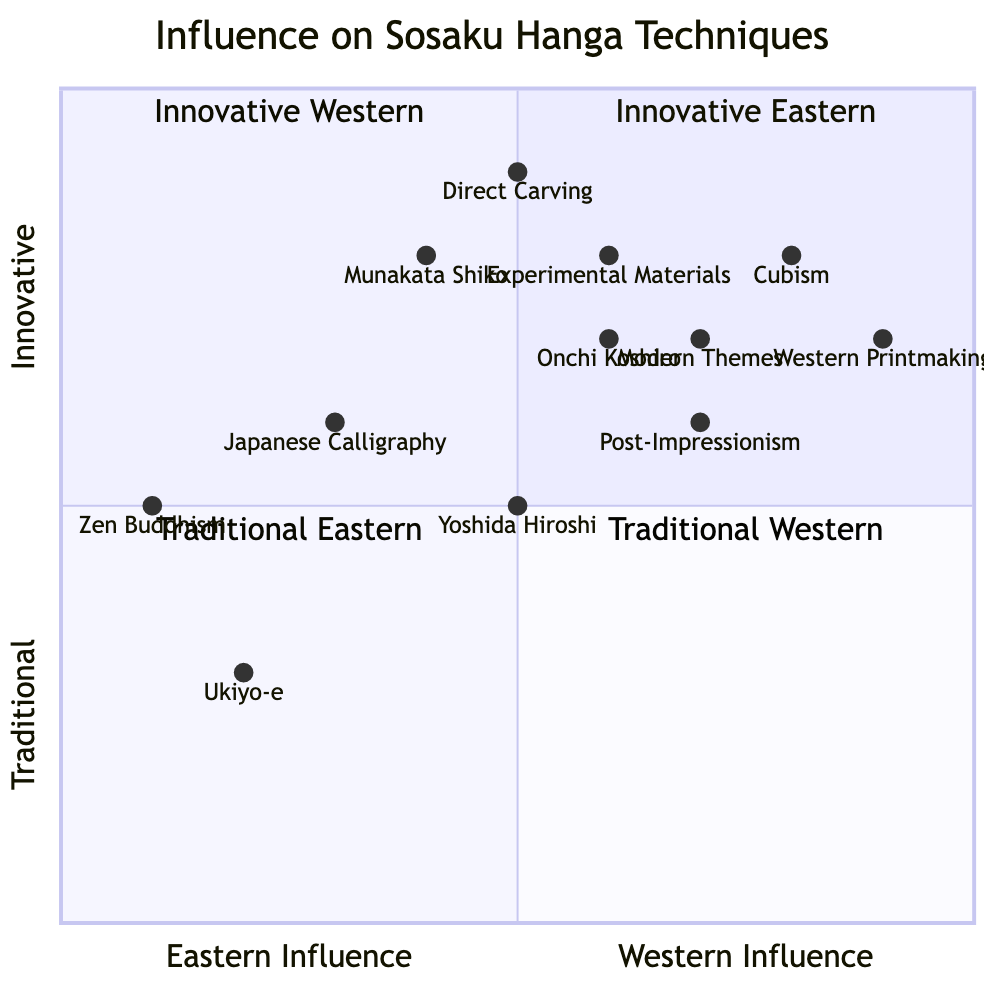What is the value of Zen Buddhism on the chart? The node representing Zen Buddhism is located at [0.1, 0.5]. The vertical coordinate, which indicates its innovative nature, is 0.5, reflecting that it is considered traditional from the perspective of innovative creativity.
Answer: [0.1, 0.5] Which technique has the highest innovative value? Looking at the y-axis values, the technique "Direct Carving" is at [0.5, 0.9], which is the highest on the chart. Therefore, this technique is identified as the most innovative.
Answer: Direct Carving How many influences are located in the Innovative Eastern quadrant? In the Innovative Eastern quadrant, there are three influences present: Japanese Calligraphy, Direct Carving, and Experimental Materials. Thus, the total count is three.
Answer: 3 Which Western influence has the lowest traditional value? Evaluating the vertical values of Western influences, Post-Impressionism has the lowest value at 0.6. This indicates that it is the least traditional among Western influences.
Answer: Post-Impressionism What is the relationship between Cubism and Western Printmaking in terms of innovative value? Both Cubism and Western Printmaking are located in the Innovative Western quadrant, with Cubism at [0.8, 0.8] and Western Printmaking at [0.9, 0.7]. While both are innovative, Cubism has a slightly lower innovative value than Western Printmaking, despite being on a similar axis.
Answer: Lower 